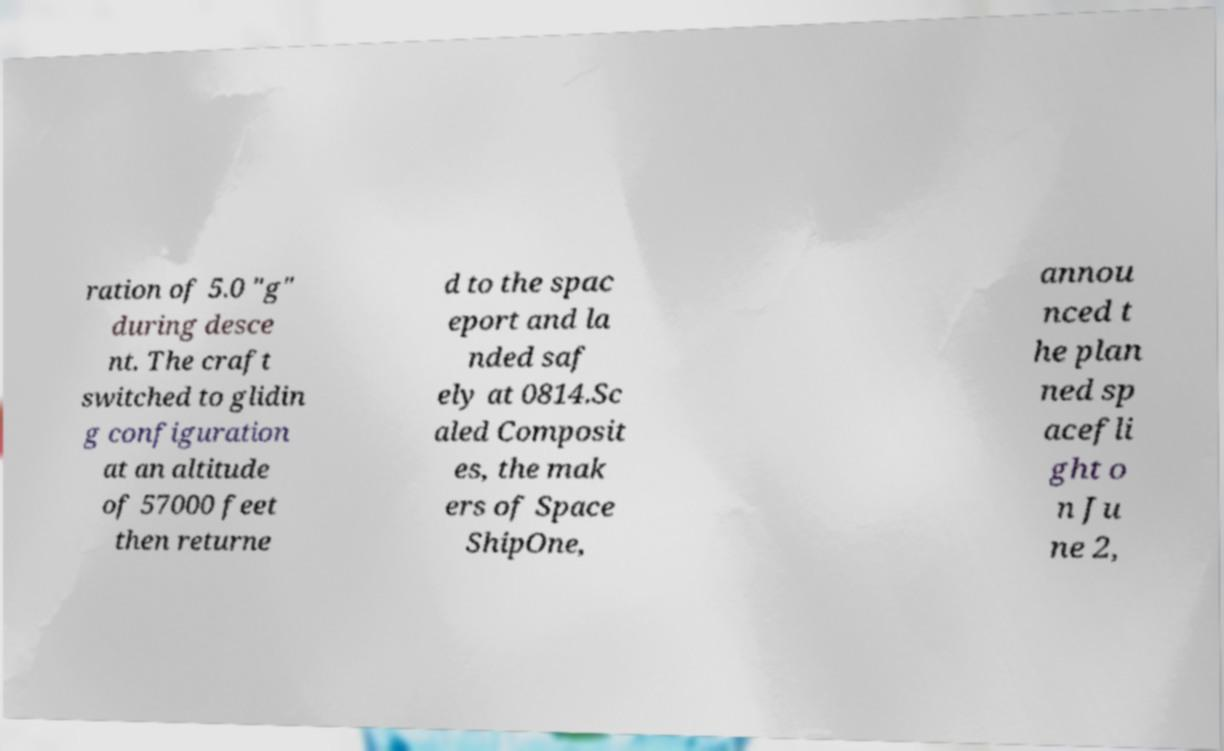Could you extract and type out the text from this image? ration of 5.0 "g" during desce nt. The craft switched to glidin g configuration at an altitude of 57000 feet then returne d to the spac eport and la nded saf ely at 0814.Sc aled Composit es, the mak ers of Space ShipOne, annou nced t he plan ned sp acefli ght o n Ju ne 2, 